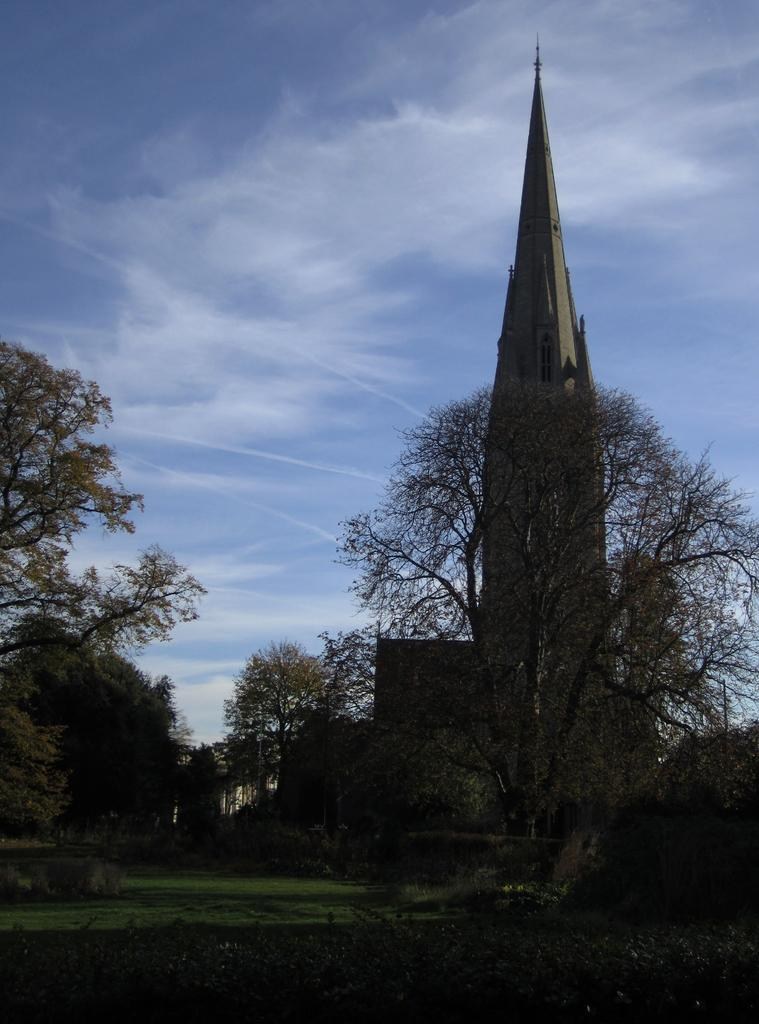What type of vegetation is on the right side of the image? There are trees on the right side of the image. Where are the trees located in relation to the ground? The trees are on the ground. What type of vegetation is on the left side of the image? There is grass on the left side of the image. Where is the grass located in relation to the ground? The grass is on the ground. What can be seen in the background of the image? There is a tower in the background of the image. What is visible in the sky in the image? There are clouds in the blue sky. What type of pickle is hanging from the tower in the image? There is no pickle present in the image; the tower is in the background, and the image features trees and grass. What fact can be learned about the bait used in the image? There is no mention of bait in the image; it features trees, grass, a tower, and clouds in the sky. 